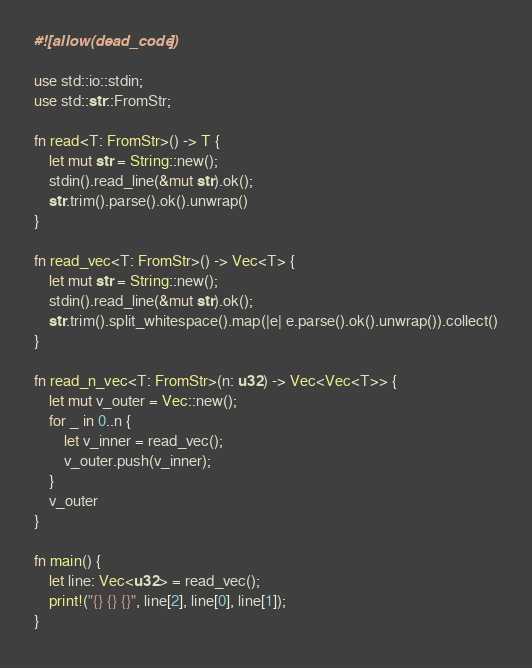<code> <loc_0><loc_0><loc_500><loc_500><_Rust_>#![allow(dead_code)]

use std::io::stdin;
use std::str::FromStr;

fn read<T: FromStr>() -> T {
    let mut str = String::new();
    stdin().read_line(&mut str).ok();
    str.trim().parse().ok().unwrap()
}

fn read_vec<T: FromStr>() -> Vec<T> {
    let mut str = String::new();
    stdin().read_line(&mut str).ok();
    str.trim().split_whitespace().map(|e| e.parse().ok().unwrap()).collect()
}

fn read_n_vec<T: FromStr>(n: u32) -> Vec<Vec<T>> {
    let mut v_outer = Vec::new();
    for _ in 0..n {
        let v_inner = read_vec();
        v_outer.push(v_inner);
    }
    v_outer
}

fn main() {
    let line: Vec<u32> = read_vec();
    print!("{} {} {}", line[2], line[0], line[1]);
}</code> 